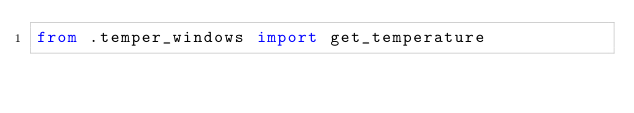<code> <loc_0><loc_0><loc_500><loc_500><_Python_>from .temper_windows import get_temperature</code> 